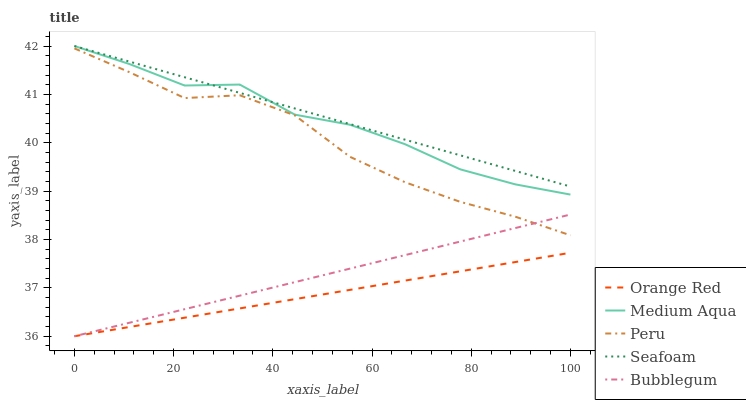Does Orange Red have the minimum area under the curve?
Answer yes or no. Yes. Does Seafoam have the maximum area under the curve?
Answer yes or no. Yes. Does Medium Aqua have the minimum area under the curve?
Answer yes or no. No. Does Medium Aqua have the maximum area under the curve?
Answer yes or no. No. Is Bubblegum the smoothest?
Answer yes or no. Yes. Is Medium Aqua the roughest?
Answer yes or no. Yes. Is Orange Red the smoothest?
Answer yes or no. No. Is Orange Red the roughest?
Answer yes or no. No. Does Medium Aqua have the lowest value?
Answer yes or no. No. Does Orange Red have the highest value?
Answer yes or no. No. Is Orange Red less than Peru?
Answer yes or no. Yes. Is Seafoam greater than Peru?
Answer yes or no. Yes. Does Orange Red intersect Peru?
Answer yes or no. No. 